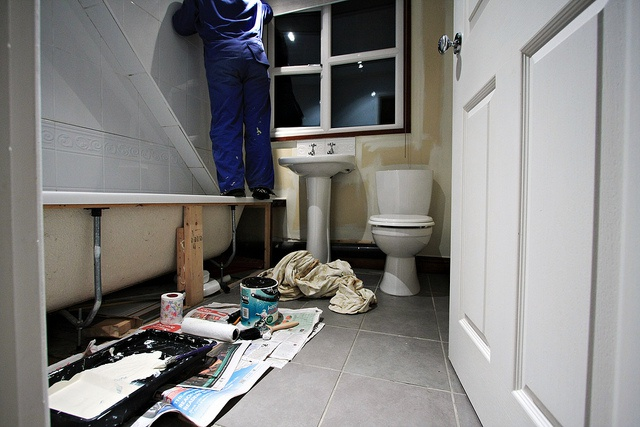Describe the objects in this image and their specific colors. I can see people in black, navy, gray, and blue tones, toilet in black, darkgray, and gray tones, and sink in black, gray, darkgray, and lightgray tones in this image. 